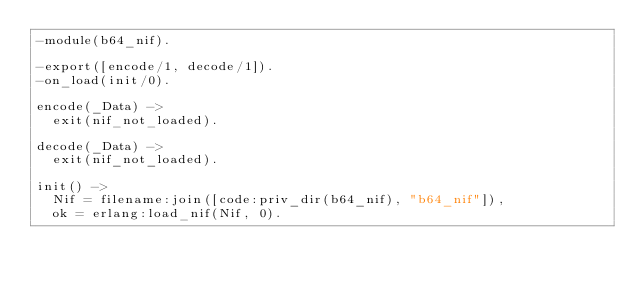<code> <loc_0><loc_0><loc_500><loc_500><_Erlang_>-module(b64_nif).

-export([encode/1, decode/1]).
-on_load(init/0).

encode(_Data) ->
  exit(nif_not_loaded).

decode(_Data) ->
  exit(nif_not_loaded).

init() ->
  Nif = filename:join([code:priv_dir(b64_nif), "b64_nif"]),
  ok = erlang:load_nif(Nif, 0).
</code> 